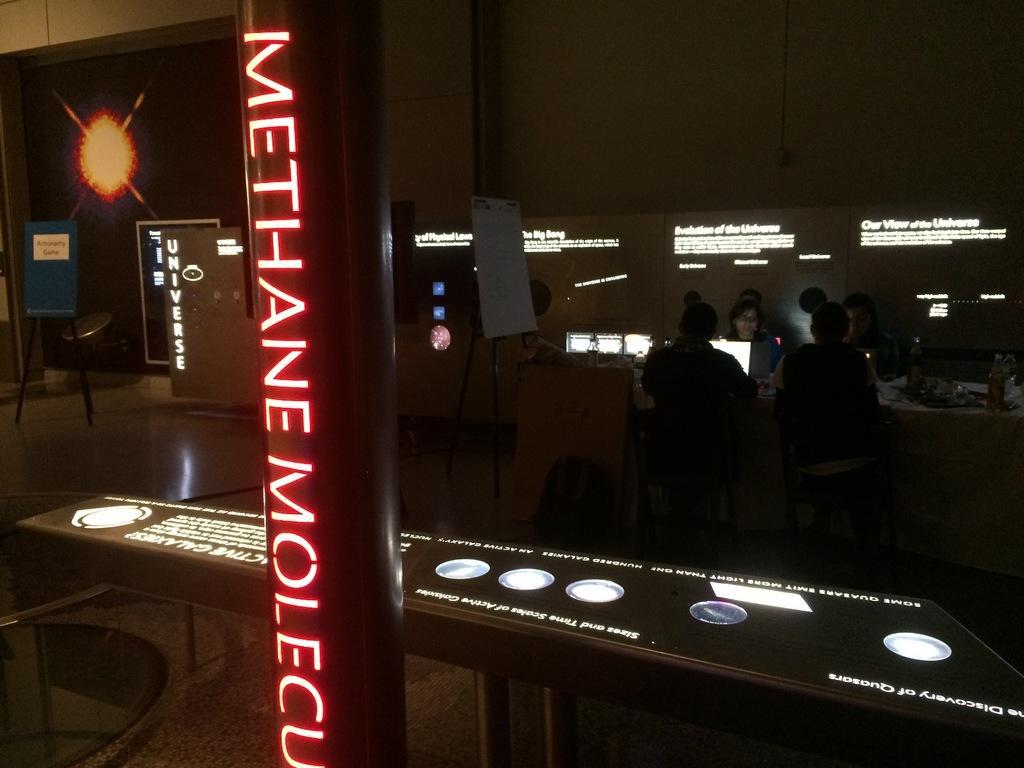Please provide a concise description of this image. This picture is taken in a dark room. In the center there is a pillar and a text printed on it which is glowing. Behind this pillar there is a table and some text printed on it which is also glowing. In the right there are four people sitting besides a table. In the background there is a wall, a board and a door. 